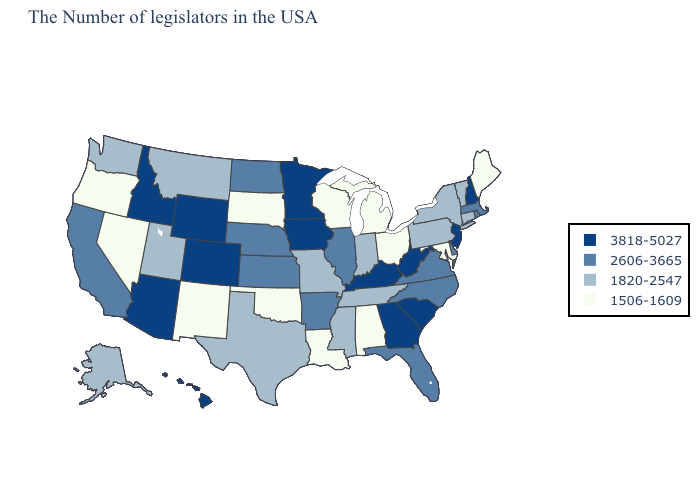Name the states that have a value in the range 3818-5027?
Give a very brief answer. New Hampshire, New Jersey, South Carolina, West Virginia, Georgia, Kentucky, Minnesota, Iowa, Wyoming, Colorado, Arizona, Idaho, Hawaii. Which states have the highest value in the USA?
Short answer required. New Hampshire, New Jersey, South Carolina, West Virginia, Georgia, Kentucky, Minnesota, Iowa, Wyoming, Colorado, Arizona, Idaho, Hawaii. Name the states that have a value in the range 1820-2547?
Write a very short answer. Vermont, Connecticut, New York, Pennsylvania, Indiana, Tennessee, Mississippi, Missouri, Texas, Utah, Montana, Washington, Alaska. Name the states that have a value in the range 3818-5027?
Quick response, please. New Hampshire, New Jersey, South Carolina, West Virginia, Georgia, Kentucky, Minnesota, Iowa, Wyoming, Colorado, Arizona, Idaho, Hawaii. Name the states that have a value in the range 3818-5027?
Quick response, please. New Hampshire, New Jersey, South Carolina, West Virginia, Georgia, Kentucky, Minnesota, Iowa, Wyoming, Colorado, Arizona, Idaho, Hawaii. Does Mississippi have the highest value in the USA?
Give a very brief answer. No. Name the states that have a value in the range 1820-2547?
Concise answer only. Vermont, Connecticut, New York, Pennsylvania, Indiana, Tennessee, Mississippi, Missouri, Texas, Utah, Montana, Washington, Alaska. Among the states that border Colorado , which have the lowest value?
Answer briefly. Oklahoma, New Mexico. Name the states that have a value in the range 1820-2547?
Write a very short answer. Vermont, Connecticut, New York, Pennsylvania, Indiana, Tennessee, Mississippi, Missouri, Texas, Utah, Montana, Washington, Alaska. What is the value of Michigan?
Answer briefly. 1506-1609. Name the states that have a value in the range 1820-2547?
Be succinct. Vermont, Connecticut, New York, Pennsylvania, Indiana, Tennessee, Mississippi, Missouri, Texas, Utah, Montana, Washington, Alaska. Does the map have missing data?
Short answer required. No. Which states hav the highest value in the MidWest?
Short answer required. Minnesota, Iowa. What is the value of Missouri?
Quick response, please. 1820-2547. Does the map have missing data?
Keep it brief. No. 